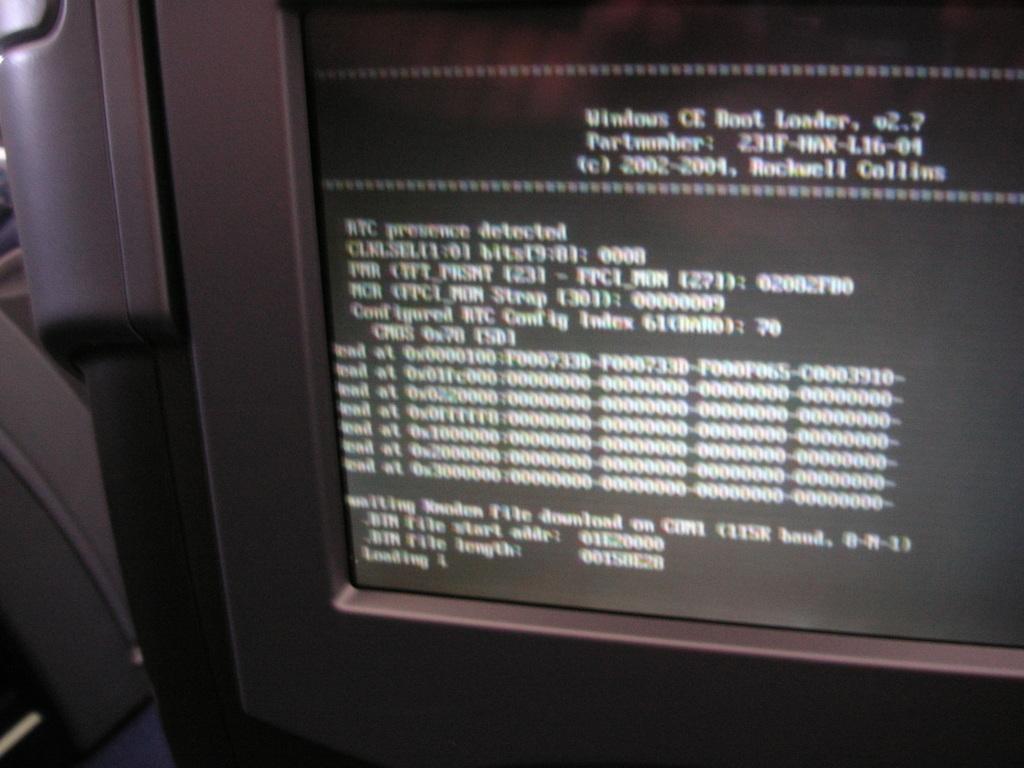What is the main object in the foreground of the image? There is a monitor in the foreground of the image. What can be seen on the monitor? Text and binary digits are displayed on the monitor. What type of face can be seen on the monitor in the image? There is no face visible on the monitor in the image; it displays text and binary digits. 